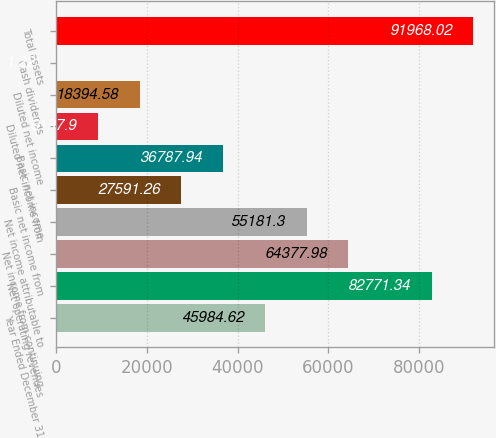<chart> <loc_0><loc_0><loc_500><loc_500><bar_chart><fcel>Year Ended December 31<fcel>Net operating revenues<fcel>Net income from continuing<fcel>Net income attributable to<fcel>Basic net income from<fcel>Basic net income<fcel>Diluted net income from<fcel>Diluted net income<fcel>Cash dividends<fcel>Total assets<nl><fcel>45984.6<fcel>82771.3<fcel>64378<fcel>55181.3<fcel>27591.3<fcel>36787.9<fcel>9197.9<fcel>18394.6<fcel>1.22<fcel>91968<nl></chart> 